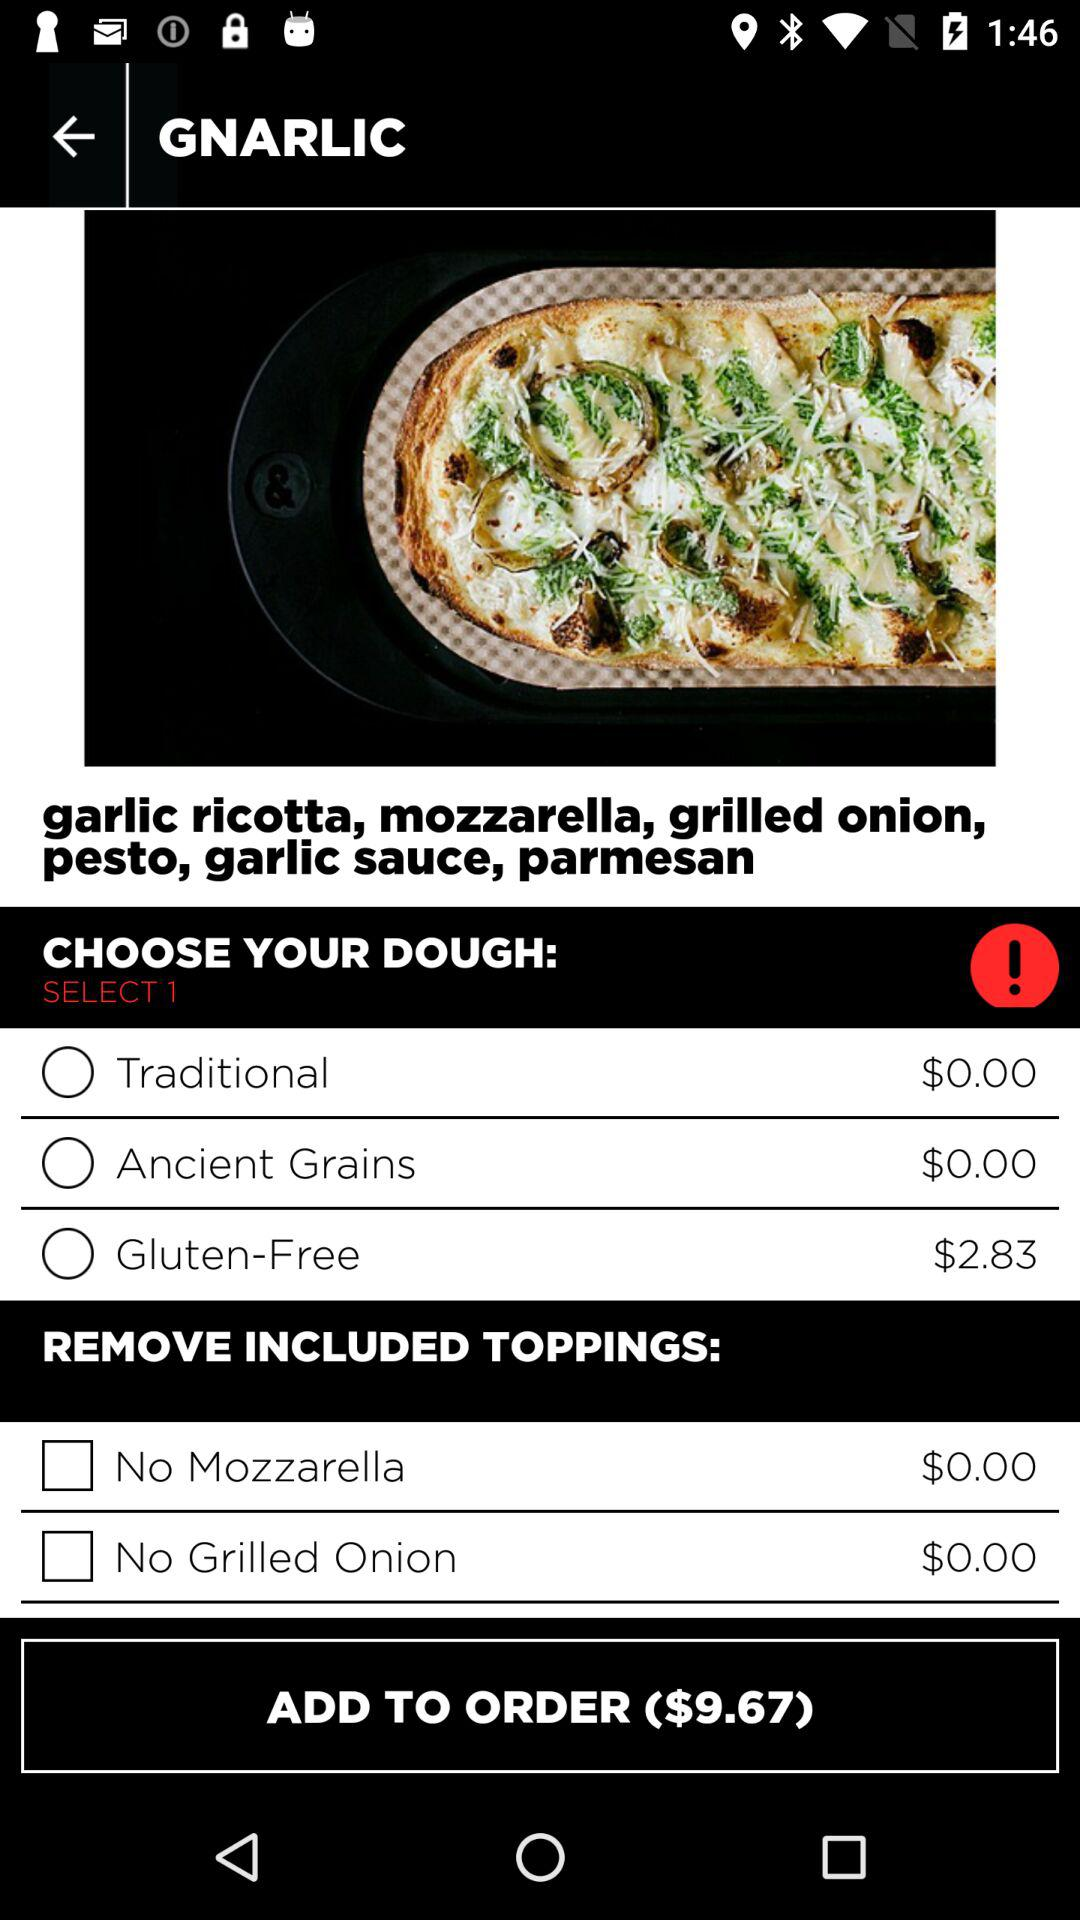What are the options for dough? The options are "Traditional", "Ancient Grains" and "Gluten-Free". 